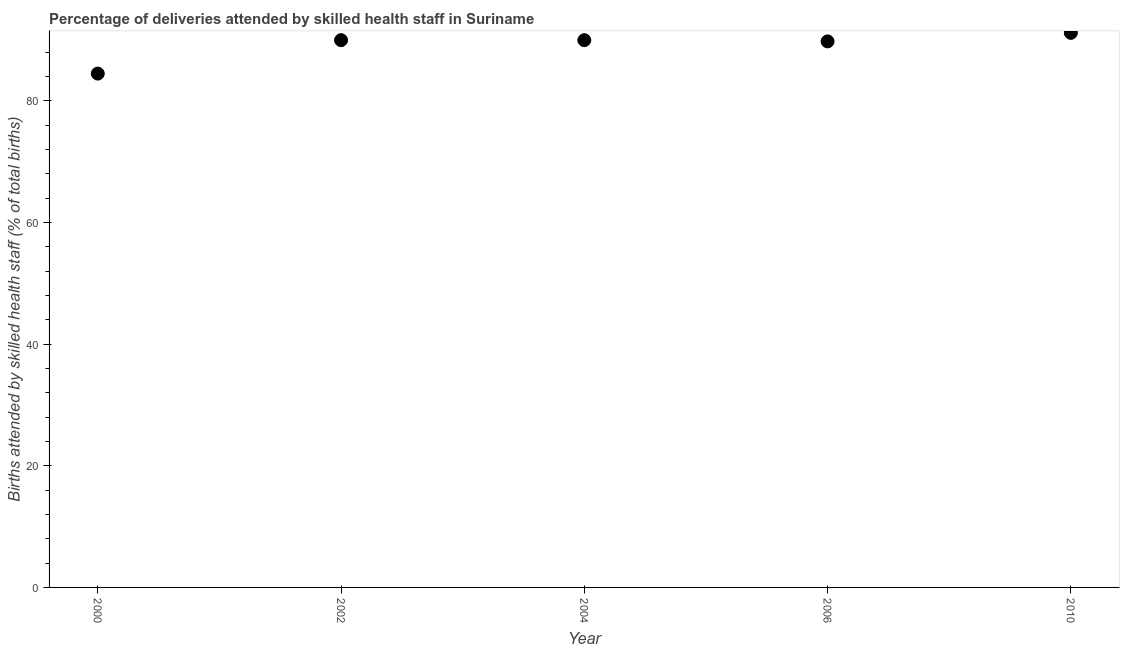What is the number of births attended by skilled health staff in 2010?
Your answer should be very brief. 91.2. Across all years, what is the maximum number of births attended by skilled health staff?
Provide a succinct answer. 91.2. Across all years, what is the minimum number of births attended by skilled health staff?
Your answer should be very brief. 84.5. In which year was the number of births attended by skilled health staff maximum?
Give a very brief answer. 2010. What is the sum of the number of births attended by skilled health staff?
Your answer should be compact. 445.5. What is the difference between the number of births attended by skilled health staff in 2006 and 2010?
Offer a terse response. -1.4. What is the average number of births attended by skilled health staff per year?
Offer a very short reply. 89.1. What is the median number of births attended by skilled health staff?
Keep it short and to the point. 90. In how many years, is the number of births attended by skilled health staff greater than 68 %?
Make the answer very short. 5. Do a majority of the years between 2002 and 2010 (inclusive) have number of births attended by skilled health staff greater than 8 %?
Offer a terse response. Yes. What is the ratio of the number of births attended by skilled health staff in 2002 to that in 2004?
Keep it short and to the point. 1. Is the difference between the number of births attended by skilled health staff in 2006 and 2010 greater than the difference between any two years?
Offer a terse response. No. What is the difference between the highest and the second highest number of births attended by skilled health staff?
Provide a succinct answer. 1.2. Is the sum of the number of births attended by skilled health staff in 2000 and 2004 greater than the maximum number of births attended by skilled health staff across all years?
Give a very brief answer. Yes. What is the difference between the highest and the lowest number of births attended by skilled health staff?
Keep it short and to the point. 6.7. In how many years, is the number of births attended by skilled health staff greater than the average number of births attended by skilled health staff taken over all years?
Your answer should be very brief. 4. How many dotlines are there?
Offer a very short reply. 1. How many years are there in the graph?
Your answer should be very brief. 5. What is the difference between two consecutive major ticks on the Y-axis?
Ensure brevity in your answer.  20. Does the graph contain any zero values?
Your answer should be compact. No. Does the graph contain grids?
Your response must be concise. No. What is the title of the graph?
Ensure brevity in your answer.  Percentage of deliveries attended by skilled health staff in Suriname. What is the label or title of the Y-axis?
Offer a terse response. Births attended by skilled health staff (% of total births). What is the Births attended by skilled health staff (% of total births) in 2000?
Give a very brief answer. 84.5. What is the Births attended by skilled health staff (% of total births) in 2006?
Provide a short and direct response. 89.8. What is the Births attended by skilled health staff (% of total births) in 2010?
Your answer should be compact. 91.2. What is the difference between the Births attended by skilled health staff (% of total births) in 2000 and 2002?
Offer a very short reply. -5.5. What is the difference between the Births attended by skilled health staff (% of total births) in 2000 and 2004?
Your answer should be compact. -5.5. What is the difference between the Births attended by skilled health staff (% of total births) in 2000 and 2006?
Provide a succinct answer. -5.3. What is the difference between the Births attended by skilled health staff (% of total births) in 2002 and 2006?
Offer a very short reply. 0.2. What is the difference between the Births attended by skilled health staff (% of total births) in 2004 and 2010?
Your answer should be compact. -1.2. What is the difference between the Births attended by skilled health staff (% of total births) in 2006 and 2010?
Make the answer very short. -1.4. What is the ratio of the Births attended by skilled health staff (% of total births) in 2000 to that in 2002?
Make the answer very short. 0.94. What is the ratio of the Births attended by skilled health staff (% of total births) in 2000 to that in 2004?
Your answer should be compact. 0.94. What is the ratio of the Births attended by skilled health staff (% of total births) in 2000 to that in 2006?
Give a very brief answer. 0.94. What is the ratio of the Births attended by skilled health staff (% of total births) in 2000 to that in 2010?
Provide a short and direct response. 0.93. What is the ratio of the Births attended by skilled health staff (% of total births) in 2002 to that in 2010?
Your answer should be very brief. 0.99. What is the ratio of the Births attended by skilled health staff (% of total births) in 2004 to that in 2010?
Give a very brief answer. 0.99. 